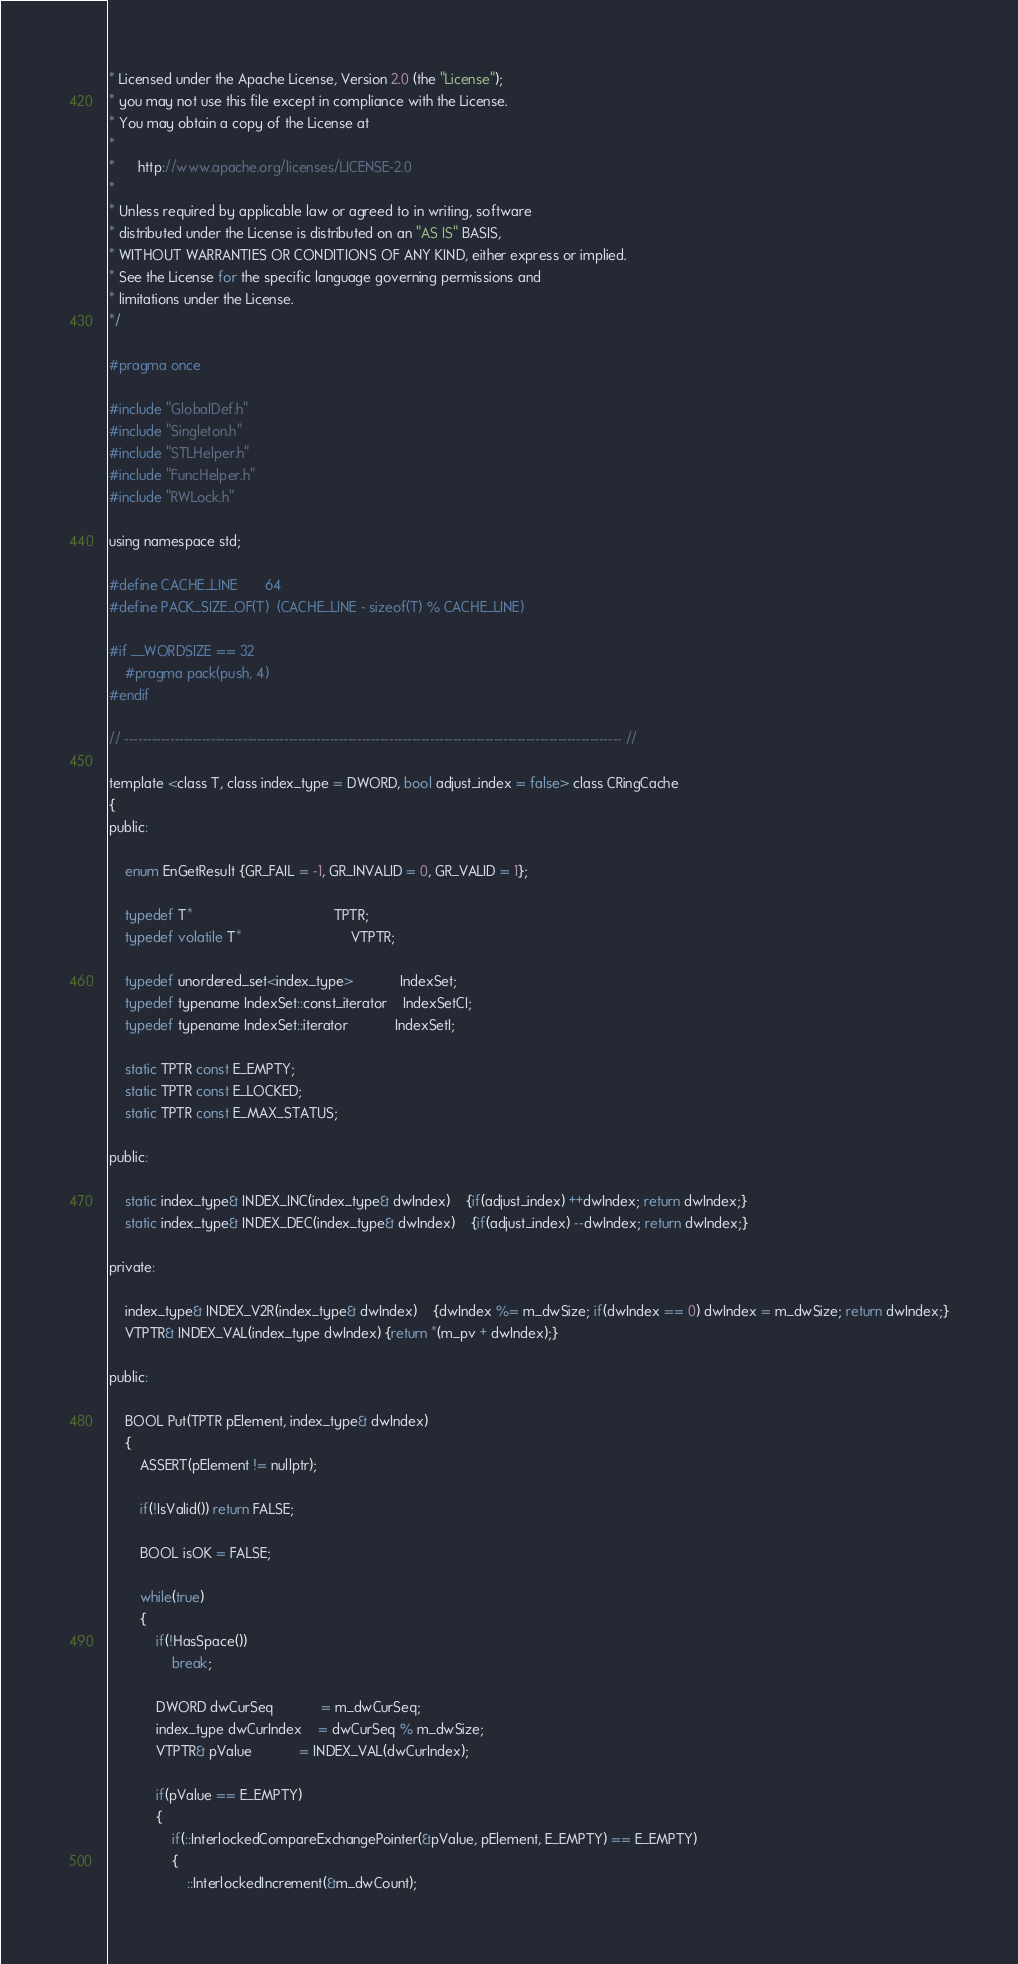<code> <loc_0><loc_0><loc_500><loc_500><_C_>* Licensed under the Apache License, Version 2.0 (the "License");
* you may not use this file except in compliance with the License.
* You may obtain a copy of the License at
*
*      http://www.apache.org/licenses/LICENSE-2.0
*
* Unless required by applicable law or agreed to in writing, software
* distributed under the License is distributed on an "AS IS" BASIS,
* WITHOUT WARRANTIES OR CONDITIONS OF ANY KIND, either express or implied.
* See the License for the specific language governing permissions and
* limitations under the License.
*/

#pragma once

#include "GlobalDef.h"
#include "Singleton.h"
#include "STLHelper.h"
#include "FuncHelper.h"
#include "RWLock.h"

using namespace std;

#define CACHE_LINE		64
#define PACK_SIZE_OF(T)	(CACHE_LINE - sizeof(T) % CACHE_LINE)

#if __WORDSIZE == 32
	#pragma pack(push, 4)
#endif

// ------------------------------------------------------------------------------------------------------------- //

template <class T, class index_type = DWORD, bool adjust_index = false> class CRingCache
{
public:

	enum EnGetResult {GR_FAIL = -1, GR_INVALID = 0, GR_VALID = 1};

	typedef T*									TPTR;
	typedef volatile T*							VTPTR;

	typedef unordered_set<index_type>			IndexSet;
	typedef typename IndexSet::const_iterator	IndexSetCI;
	typedef typename IndexSet::iterator			IndexSetI;

	static TPTR const E_EMPTY;
	static TPTR const E_LOCKED;
	static TPTR const E_MAX_STATUS;

public:

	static index_type& INDEX_INC(index_type& dwIndex)	{if(adjust_index) ++dwIndex; return dwIndex;}
	static index_type& INDEX_DEC(index_type& dwIndex)	{if(adjust_index) --dwIndex; return dwIndex;}

private:

	index_type& INDEX_V2R(index_type& dwIndex)	{dwIndex %= m_dwSize; if(dwIndex == 0) dwIndex = m_dwSize; return dwIndex;}
	VTPTR& INDEX_VAL(index_type dwIndex) {return *(m_pv + dwIndex);}

public:

	BOOL Put(TPTR pElement, index_type& dwIndex)
	{
		ASSERT(pElement != nullptr);

		if(!IsValid()) return FALSE;

		BOOL isOK = FALSE;

		while(true)
		{
			if(!HasSpace())
				break;

			DWORD dwCurSeq			= m_dwCurSeq;
			index_type dwCurIndex	= dwCurSeq % m_dwSize;
			VTPTR& pValue			= INDEX_VAL(dwCurIndex);

			if(pValue == E_EMPTY)
			{
				if(::InterlockedCompareExchangePointer(&pValue, pElement, E_EMPTY) == E_EMPTY)
				{
					::InterlockedIncrement(&m_dwCount);</code> 